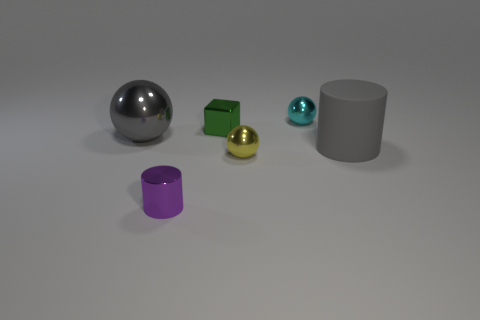Can you tell me what the large grey object is on the right? The large grey object on the right is a cylinder. It has a circular base and appears smooth, standing tall in contrast to the other objects. 